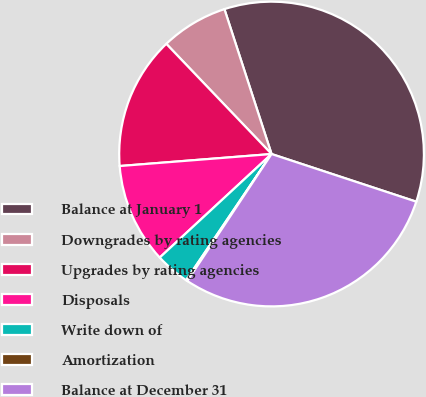<chart> <loc_0><loc_0><loc_500><loc_500><pie_chart><fcel>Balance at January 1<fcel>Downgrades by rating agencies<fcel>Upgrades by rating agencies<fcel>Disposals<fcel>Write down of<fcel>Amortization<fcel>Balance at December 31<nl><fcel>35.07%<fcel>7.13%<fcel>14.12%<fcel>10.63%<fcel>3.64%<fcel>0.15%<fcel>29.26%<nl></chart> 